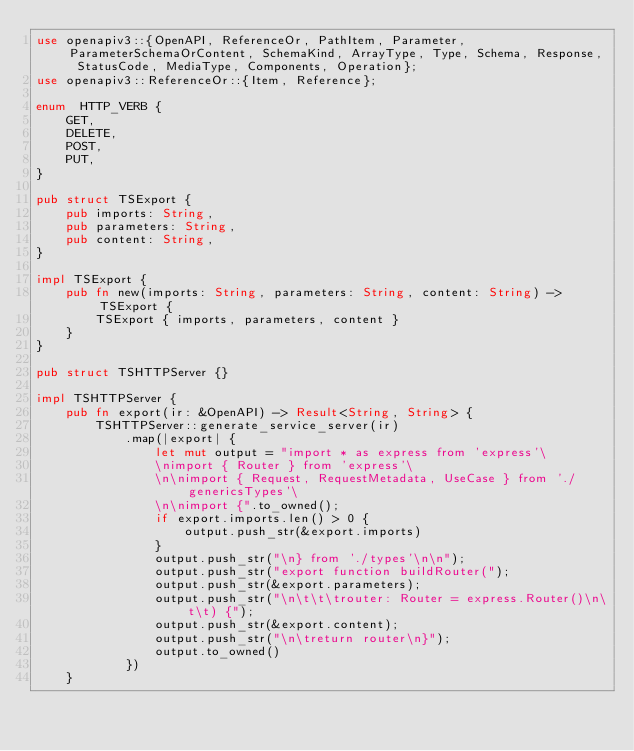<code> <loc_0><loc_0><loc_500><loc_500><_Rust_>use openapiv3::{OpenAPI, ReferenceOr, PathItem, Parameter, ParameterSchemaOrContent, SchemaKind, ArrayType, Type, Schema, Response, StatusCode, MediaType, Components, Operation};
use openapiv3::ReferenceOr::{Item, Reference};

enum  HTTP_VERB {
    GET,
    DELETE,
    POST,
    PUT,
}

pub struct TSExport {
    pub imports: String,
    pub parameters: String,
    pub content: String,
}

impl TSExport {
    pub fn new(imports: String, parameters: String, content: String) -> TSExport {
        TSExport { imports, parameters, content }
    }
}

pub struct TSHTTPServer {}

impl TSHTTPServer {
    pub fn export(ir: &OpenAPI) -> Result<String, String> {
        TSHTTPServer::generate_service_server(ir)
            .map(|export| {
                let mut output = "import * as express from 'express'\
                \nimport { Router } from 'express'\
                \n\nimport { Request, RequestMetadata, UseCase } from './genericsTypes'\
                \n\nimport {".to_owned();
                if export.imports.len() > 0 {
                    output.push_str(&export.imports)
                }
                output.push_str("\n} from './types'\n\n");
                output.push_str("export function buildRouter(");
                output.push_str(&export.parameters);
                output.push_str("\n\t\t\trouter: Router = express.Router()\n\t\t) {");
                output.push_str(&export.content);
                output.push_str("\n\treturn router\n}");
                output.to_owned()
            })
    }
</code> 